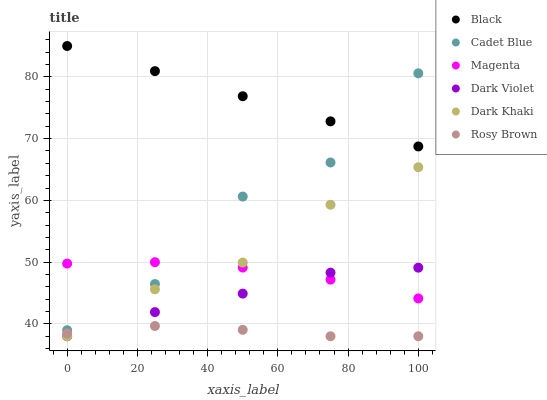Does Rosy Brown have the minimum area under the curve?
Answer yes or no. Yes. Does Black have the maximum area under the curve?
Answer yes or no. Yes. Does Dark Violet have the minimum area under the curve?
Answer yes or no. No. Does Dark Violet have the maximum area under the curve?
Answer yes or no. No. Is Black the smoothest?
Answer yes or no. Yes. Is Cadet Blue the roughest?
Answer yes or no. Yes. Is Rosy Brown the smoothest?
Answer yes or no. No. Is Rosy Brown the roughest?
Answer yes or no. No. Does Rosy Brown have the lowest value?
Answer yes or no. Yes. Does Black have the lowest value?
Answer yes or no. No. Does Black have the highest value?
Answer yes or no. Yes. Does Dark Violet have the highest value?
Answer yes or no. No. Is Rosy Brown less than Cadet Blue?
Answer yes or no. Yes. Is Cadet Blue greater than Rosy Brown?
Answer yes or no. Yes. Does Rosy Brown intersect Dark Violet?
Answer yes or no. Yes. Is Rosy Brown less than Dark Violet?
Answer yes or no. No. Is Rosy Brown greater than Dark Violet?
Answer yes or no. No. Does Rosy Brown intersect Cadet Blue?
Answer yes or no. No. 